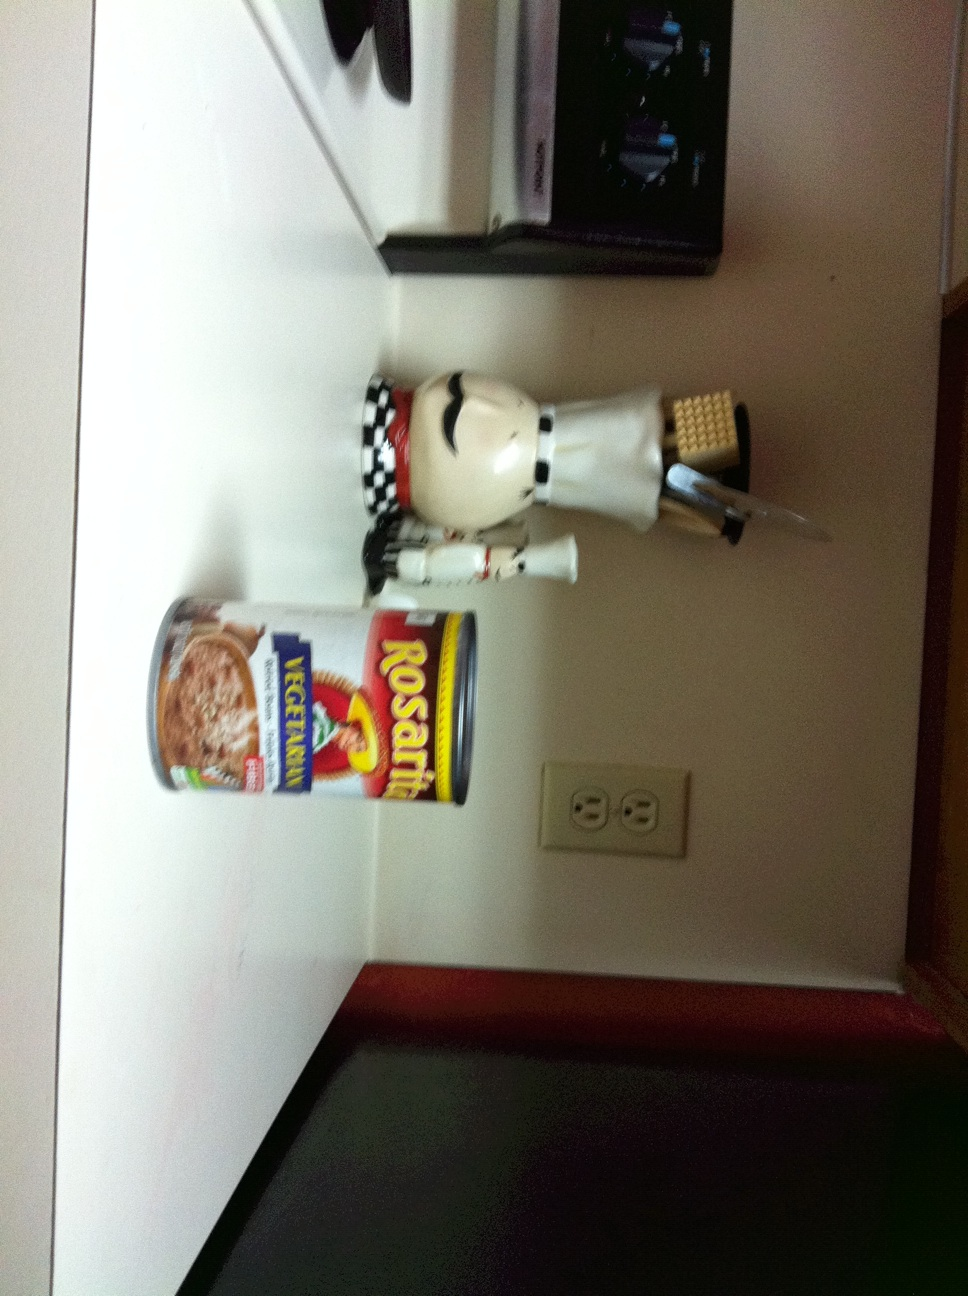Does this have Jalapenos? The image shows a can of Rosarita Ice Cream and a decorative chef statuette. There are no jalapenos visible in the image. It's just an ice cream can and a decoration item on the kitchen counter. 